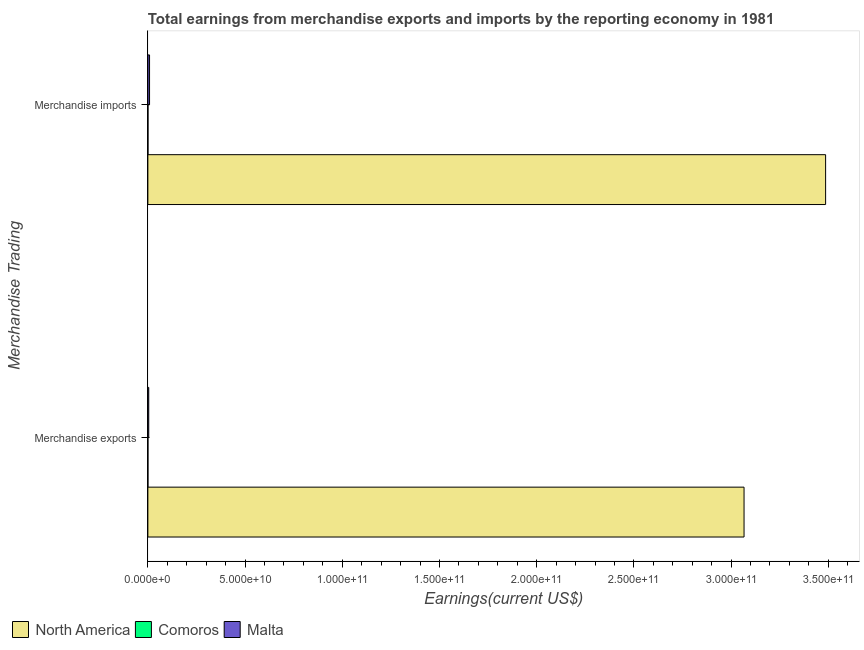How many different coloured bars are there?
Provide a short and direct response. 3. How many groups of bars are there?
Keep it short and to the point. 2. Are the number of bars on each tick of the Y-axis equal?
Ensure brevity in your answer.  Yes. How many bars are there on the 2nd tick from the top?
Ensure brevity in your answer.  3. How many bars are there on the 2nd tick from the bottom?
Offer a terse response. 3. What is the earnings from merchandise imports in Comoros?
Keep it short and to the point. 4.88e+07. Across all countries, what is the maximum earnings from merchandise exports?
Your response must be concise. 3.07e+11. Across all countries, what is the minimum earnings from merchandise imports?
Provide a short and direct response. 4.88e+07. In which country was the earnings from merchandise imports maximum?
Your response must be concise. North America. In which country was the earnings from merchandise imports minimum?
Give a very brief answer. Comoros. What is the total earnings from merchandise imports in the graph?
Your answer should be very brief. 3.50e+11. What is the difference between the earnings from merchandise imports in North America and that in Malta?
Your answer should be very brief. 3.48e+11. What is the difference between the earnings from merchandise exports in Malta and the earnings from merchandise imports in Comoros?
Your answer should be compact. 4.01e+08. What is the average earnings from merchandise exports per country?
Make the answer very short. 1.02e+11. What is the difference between the earnings from merchandise exports and earnings from merchandise imports in Malta?
Offer a terse response. -4.11e+08. In how many countries, is the earnings from merchandise exports greater than 150000000000 US$?
Ensure brevity in your answer.  1. What is the ratio of the earnings from merchandise exports in North America to that in Comoros?
Offer a very short reply. 1.15e+04. In how many countries, is the earnings from merchandise imports greater than the average earnings from merchandise imports taken over all countries?
Provide a short and direct response. 1. What does the 2nd bar from the bottom in Merchandise exports represents?
Provide a succinct answer. Comoros. Does the graph contain any zero values?
Keep it short and to the point. No. Does the graph contain grids?
Keep it short and to the point. No. How are the legend labels stacked?
Ensure brevity in your answer.  Horizontal. What is the title of the graph?
Your answer should be very brief. Total earnings from merchandise exports and imports by the reporting economy in 1981. Does "Lao PDR" appear as one of the legend labels in the graph?
Offer a very short reply. No. What is the label or title of the X-axis?
Offer a terse response. Earnings(current US$). What is the label or title of the Y-axis?
Ensure brevity in your answer.  Merchandise Trading. What is the Earnings(current US$) in North America in Merchandise exports?
Provide a succinct answer. 3.07e+11. What is the Earnings(current US$) in Comoros in Merchandise exports?
Make the answer very short. 2.68e+07. What is the Earnings(current US$) in Malta in Merchandise exports?
Keep it short and to the point. 4.50e+08. What is the Earnings(current US$) of North America in Merchandise imports?
Provide a succinct answer. 3.49e+11. What is the Earnings(current US$) of Comoros in Merchandise imports?
Provide a short and direct response. 4.88e+07. What is the Earnings(current US$) of Malta in Merchandise imports?
Give a very brief answer. 8.60e+08. Across all Merchandise Trading, what is the maximum Earnings(current US$) of North America?
Keep it short and to the point. 3.49e+11. Across all Merchandise Trading, what is the maximum Earnings(current US$) of Comoros?
Ensure brevity in your answer.  4.88e+07. Across all Merchandise Trading, what is the maximum Earnings(current US$) of Malta?
Offer a very short reply. 8.60e+08. Across all Merchandise Trading, what is the minimum Earnings(current US$) in North America?
Your answer should be very brief. 3.07e+11. Across all Merchandise Trading, what is the minimum Earnings(current US$) of Comoros?
Ensure brevity in your answer.  2.68e+07. Across all Merchandise Trading, what is the minimum Earnings(current US$) of Malta?
Provide a short and direct response. 4.50e+08. What is the total Earnings(current US$) in North America in the graph?
Offer a very short reply. 6.55e+11. What is the total Earnings(current US$) of Comoros in the graph?
Your answer should be compact. 7.56e+07. What is the total Earnings(current US$) in Malta in the graph?
Give a very brief answer. 1.31e+09. What is the difference between the Earnings(current US$) in North America in Merchandise exports and that in Merchandise imports?
Provide a succinct answer. -4.20e+1. What is the difference between the Earnings(current US$) in Comoros in Merchandise exports and that in Merchandise imports?
Provide a succinct answer. -2.20e+07. What is the difference between the Earnings(current US$) in Malta in Merchandise exports and that in Merchandise imports?
Offer a very short reply. -4.11e+08. What is the difference between the Earnings(current US$) in North America in Merchandise exports and the Earnings(current US$) in Comoros in Merchandise imports?
Offer a very short reply. 3.07e+11. What is the difference between the Earnings(current US$) of North America in Merchandise exports and the Earnings(current US$) of Malta in Merchandise imports?
Provide a short and direct response. 3.06e+11. What is the difference between the Earnings(current US$) in Comoros in Merchandise exports and the Earnings(current US$) in Malta in Merchandise imports?
Your answer should be compact. -8.34e+08. What is the average Earnings(current US$) of North America per Merchandise Trading?
Offer a terse response. 3.28e+11. What is the average Earnings(current US$) in Comoros per Merchandise Trading?
Offer a very short reply. 3.78e+07. What is the average Earnings(current US$) of Malta per Merchandise Trading?
Make the answer very short. 6.55e+08. What is the difference between the Earnings(current US$) in North America and Earnings(current US$) in Comoros in Merchandise exports?
Your answer should be compact. 3.07e+11. What is the difference between the Earnings(current US$) of North America and Earnings(current US$) of Malta in Merchandise exports?
Offer a terse response. 3.06e+11. What is the difference between the Earnings(current US$) in Comoros and Earnings(current US$) in Malta in Merchandise exports?
Your answer should be very brief. -4.23e+08. What is the difference between the Earnings(current US$) of North America and Earnings(current US$) of Comoros in Merchandise imports?
Ensure brevity in your answer.  3.49e+11. What is the difference between the Earnings(current US$) in North America and Earnings(current US$) in Malta in Merchandise imports?
Offer a very short reply. 3.48e+11. What is the difference between the Earnings(current US$) in Comoros and Earnings(current US$) in Malta in Merchandise imports?
Keep it short and to the point. -8.12e+08. What is the ratio of the Earnings(current US$) in North America in Merchandise exports to that in Merchandise imports?
Your answer should be compact. 0.88. What is the ratio of the Earnings(current US$) of Comoros in Merchandise exports to that in Merchandise imports?
Your answer should be compact. 0.55. What is the ratio of the Earnings(current US$) in Malta in Merchandise exports to that in Merchandise imports?
Provide a succinct answer. 0.52. What is the difference between the highest and the second highest Earnings(current US$) in North America?
Ensure brevity in your answer.  4.20e+1. What is the difference between the highest and the second highest Earnings(current US$) in Comoros?
Keep it short and to the point. 2.20e+07. What is the difference between the highest and the second highest Earnings(current US$) of Malta?
Provide a short and direct response. 4.11e+08. What is the difference between the highest and the lowest Earnings(current US$) of North America?
Ensure brevity in your answer.  4.20e+1. What is the difference between the highest and the lowest Earnings(current US$) in Comoros?
Your response must be concise. 2.20e+07. What is the difference between the highest and the lowest Earnings(current US$) in Malta?
Make the answer very short. 4.11e+08. 